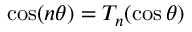<formula> <loc_0><loc_0><loc_500><loc_500>\cos ( n \theta ) = T _ { n } ( \cos \theta )</formula> 